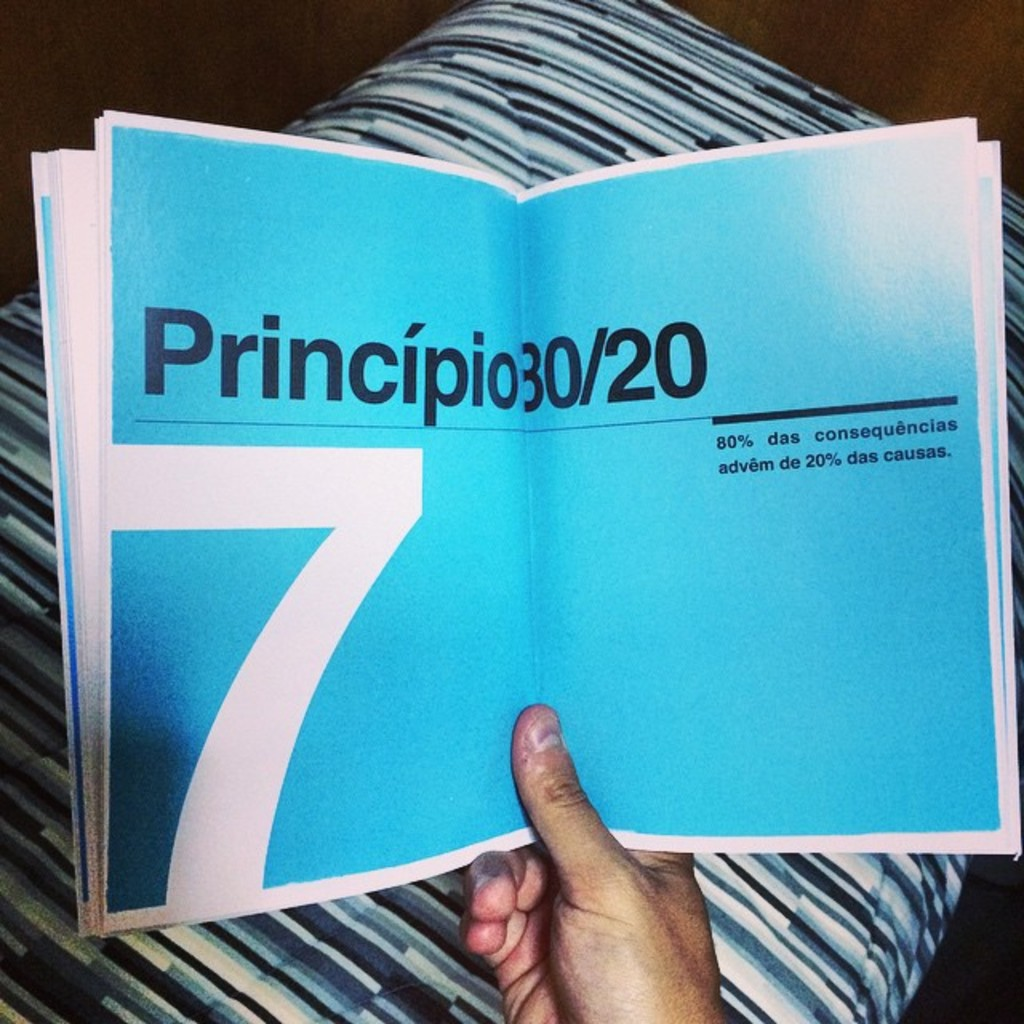What might be the significance of the number 7 in the context of this book? In the context of the book, the number '7' seen on the page could indicate a chapter or a section. Given the book deals with efficiency principles such as 'Princípio30/20', the number might introduce a specific list or set of examples that illustrate the principle's application in various scenarios, aiming to provide the reader with a structured understanding of how minor inputs can lead to major outputs. 